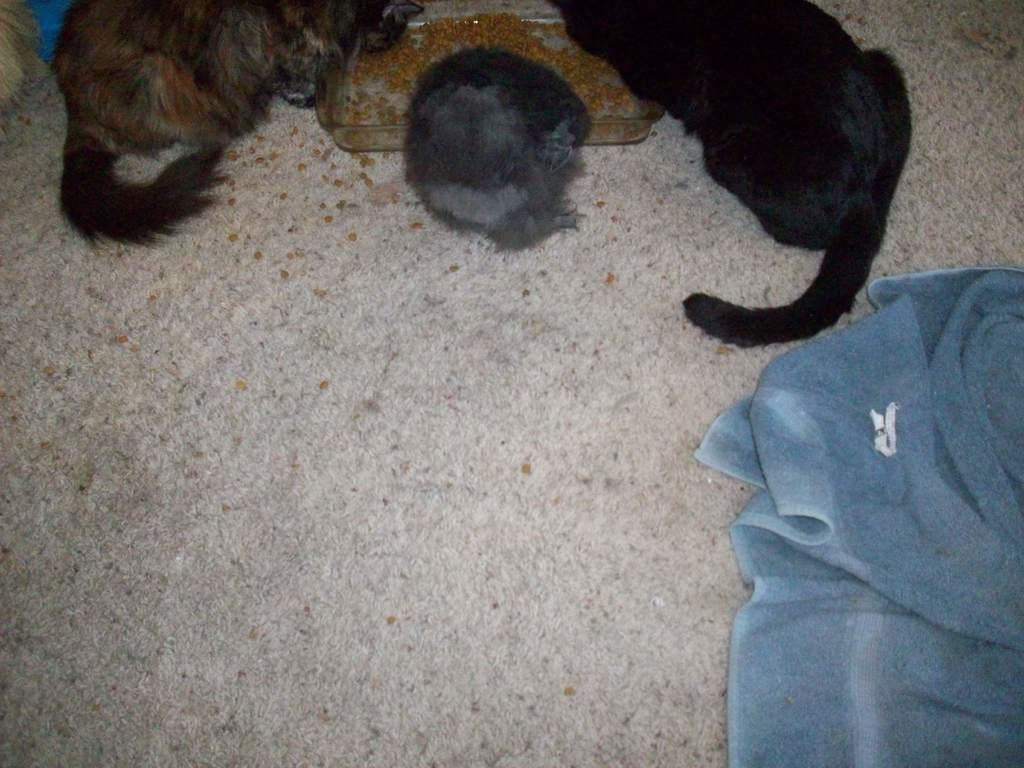Could you give a brief overview of what you see in this image? In this picture I can see a food item in a square bowl, there are animals and a blanket on the floor. 